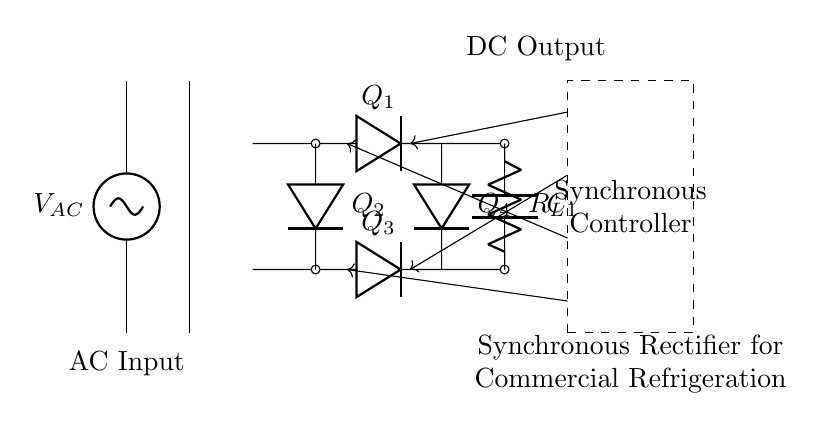What is the AC input voltage of this circuit? The AC input voltage is represented by the label VAC at the source on the left side of the diagram.
Answer: VAC What type of rectifier is shown in the circuit? The circuit diagram depicts a synchronous rectifier, as indicated by the presence of the synchronous controller box and the arrangement of the diodes labeled Q1, Q2, Q3, and Q4.
Answer: Synchronous rectifier How many diodes are used in this rectifier? The rectifier uses four diodes, which are labeled Q1, Q2, Q3, and Q4 in the diagram.
Answer: Four What is the role of the output capacitor in this circuit? The output capacitor labeled C1 smooths the DC output by filtering voltage fluctuations, allowing for a more stable output voltage to the load (RL).
Answer: Filtering How does the synchronous controller improve efficiency? The synchronous controller allows the diodes to be turned on and off in coordination with the AC input, minimizing voltage drop and thus improving energy efficiency in the rectification process.
Answer: Minimizes voltage drop What is connected to the output of the rectifier? The load connected to the output is represented by the resistor labeled RL, which indicates the component that will use the rectified DC power.
Answer: Resistor RL What circuit configuration is this diagram representing? The diagram represents a full-bridge rectifier configuration, indicated by the arrangement of the four diodes connected to the AC source and the output capacitor to produce a DC output.
Answer: Full-bridge rectifier 